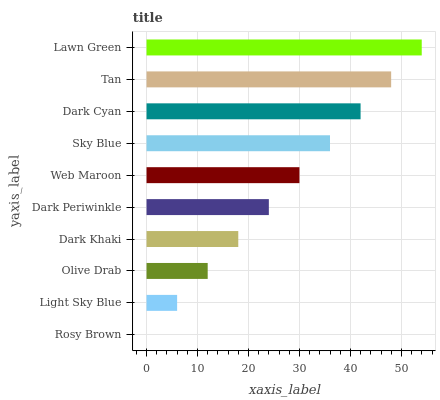Is Rosy Brown the minimum?
Answer yes or no. Yes. Is Lawn Green the maximum?
Answer yes or no. Yes. Is Light Sky Blue the minimum?
Answer yes or no. No. Is Light Sky Blue the maximum?
Answer yes or no. No. Is Light Sky Blue greater than Rosy Brown?
Answer yes or no. Yes. Is Rosy Brown less than Light Sky Blue?
Answer yes or no. Yes. Is Rosy Brown greater than Light Sky Blue?
Answer yes or no. No. Is Light Sky Blue less than Rosy Brown?
Answer yes or no. No. Is Web Maroon the high median?
Answer yes or no. Yes. Is Dark Periwinkle the low median?
Answer yes or no. Yes. Is Rosy Brown the high median?
Answer yes or no. No. Is Lawn Green the low median?
Answer yes or no. No. 